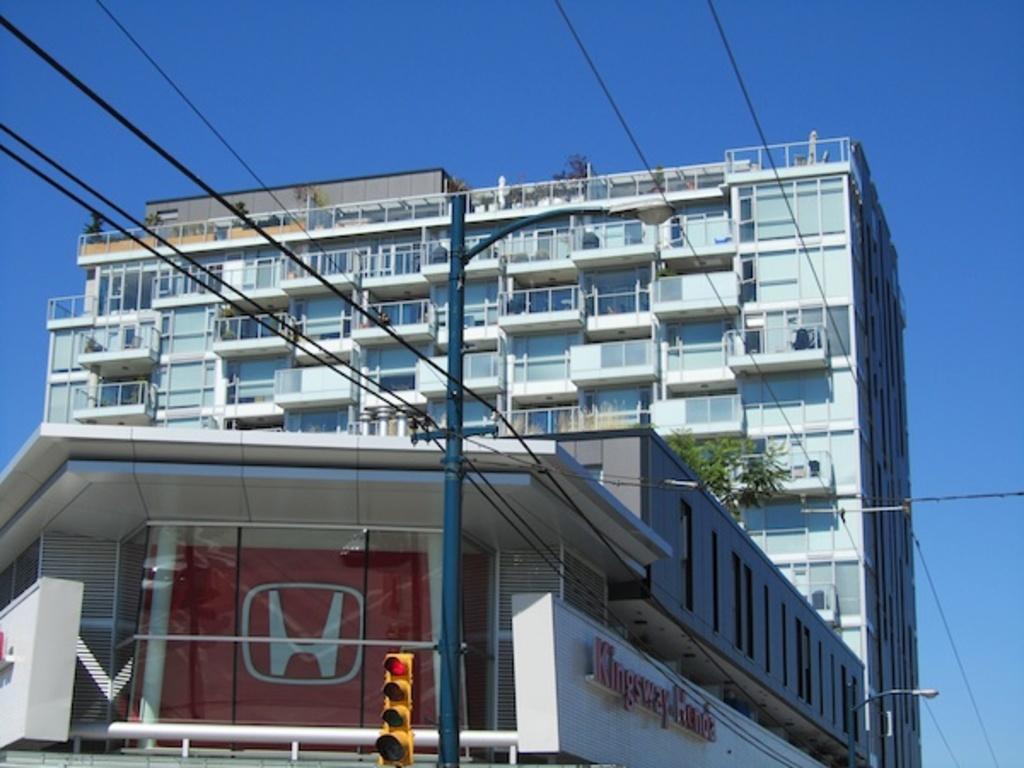Describe this image in one or two sentences. In this image we can see a building with windows. We can also see traffic light, board, pole with wires, plant and the sky. 